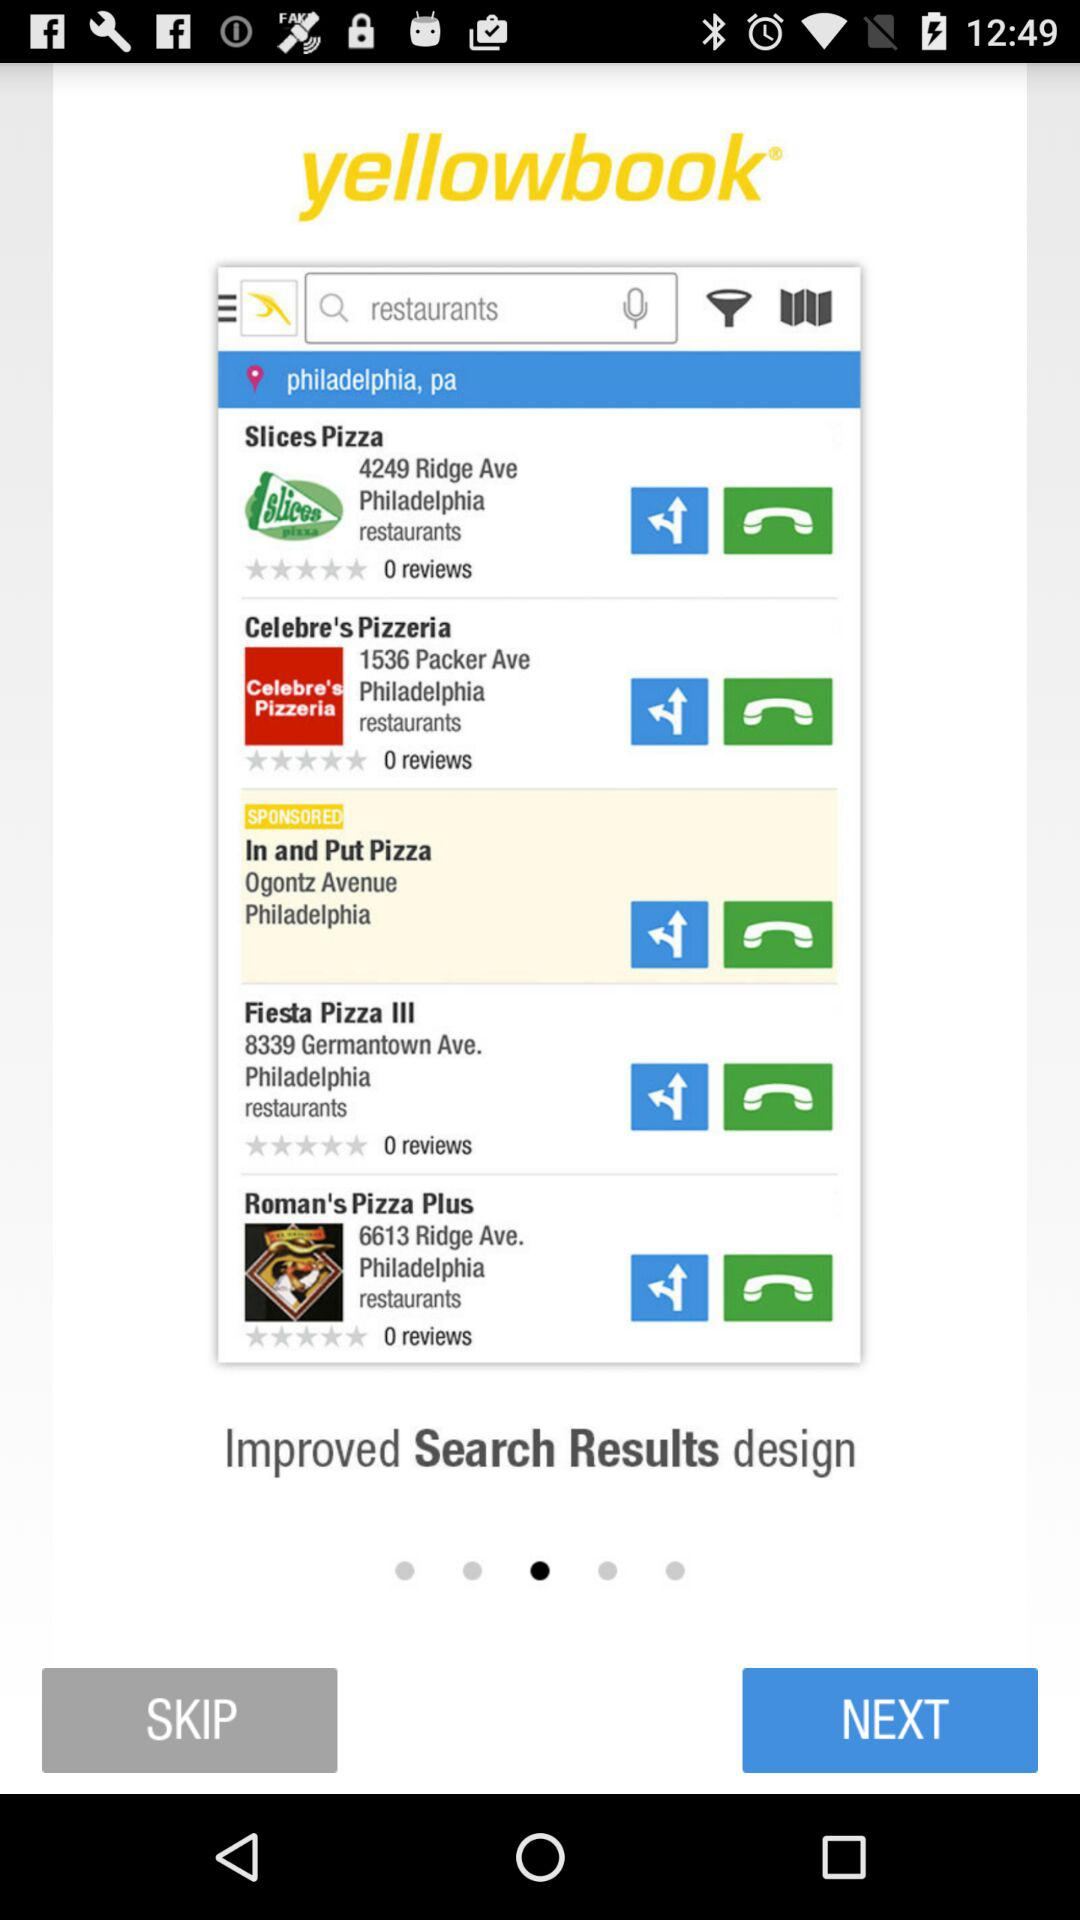What is the address of "Roman's Pizza Plus"? The address is 6613 Ridge Ave. Philadelphia. 